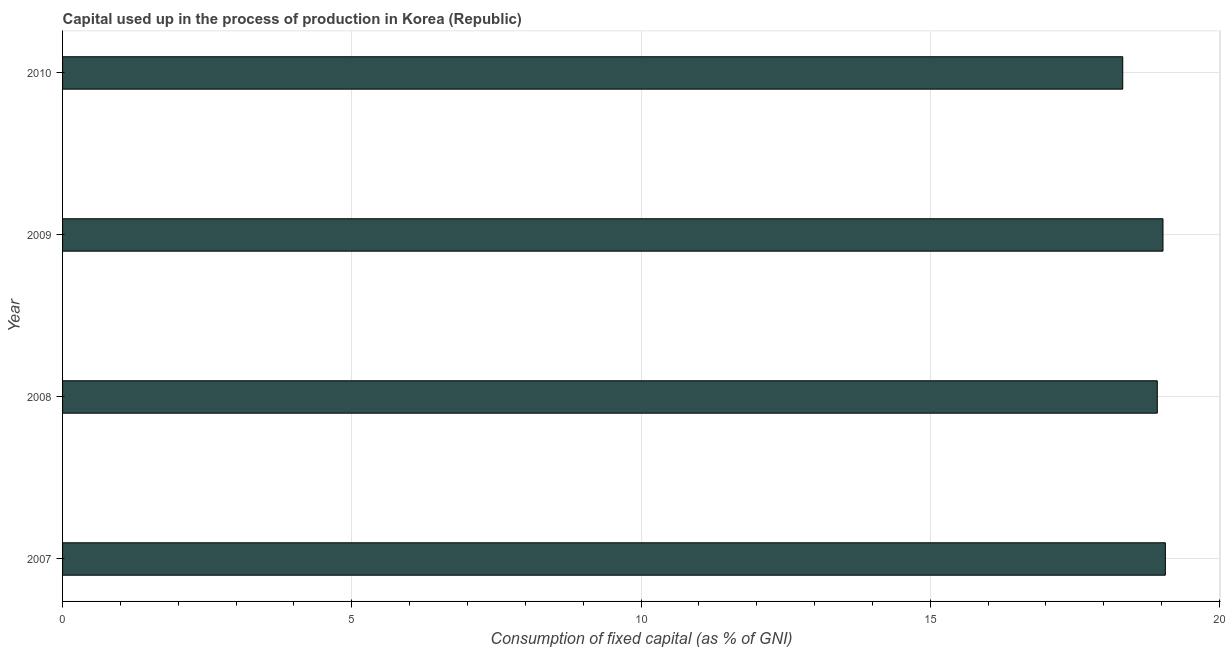Does the graph contain grids?
Offer a very short reply. Yes. What is the title of the graph?
Keep it short and to the point. Capital used up in the process of production in Korea (Republic). What is the label or title of the X-axis?
Provide a succinct answer. Consumption of fixed capital (as % of GNI). What is the consumption of fixed capital in 2009?
Your response must be concise. 19.02. Across all years, what is the maximum consumption of fixed capital?
Your answer should be very brief. 19.06. Across all years, what is the minimum consumption of fixed capital?
Offer a terse response. 18.33. In which year was the consumption of fixed capital maximum?
Offer a terse response. 2007. What is the sum of the consumption of fixed capital?
Ensure brevity in your answer.  75.34. What is the difference between the consumption of fixed capital in 2008 and 2009?
Offer a terse response. -0.1. What is the average consumption of fixed capital per year?
Your response must be concise. 18.84. What is the median consumption of fixed capital?
Your answer should be compact. 18.97. In how many years, is the consumption of fixed capital greater than 15 %?
Provide a short and direct response. 4. Do a majority of the years between 2008 and 2009 (inclusive) have consumption of fixed capital greater than 3 %?
Ensure brevity in your answer.  Yes. What is the ratio of the consumption of fixed capital in 2007 to that in 2008?
Offer a terse response. 1.01. Is the difference between the consumption of fixed capital in 2008 and 2010 greater than the difference between any two years?
Offer a terse response. No. What is the difference between the highest and the second highest consumption of fixed capital?
Offer a terse response. 0.04. Is the sum of the consumption of fixed capital in 2007 and 2010 greater than the maximum consumption of fixed capital across all years?
Your answer should be very brief. Yes. What is the difference between the highest and the lowest consumption of fixed capital?
Your answer should be compact. 0.74. In how many years, is the consumption of fixed capital greater than the average consumption of fixed capital taken over all years?
Offer a very short reply. 3. Are all the bars in the graph horizontal?
Your answer should be very brief. Yes. Are the values on the major ticks of X-axis written in scientific E-notation?
Your answer should be compact. No. What is the Consumption of fixed capital (as % of GNI) in 2007?
Offer a very short reply. 19.06. What is the Consumption of fixed capital (as % of GNI) in 2008?
Offer a very short reply. 18.92. What is the Consumption of fixed capital (as % of GNI) of 2009?
Your answer should be very brief. 19.02. What is the Consumption of fixed capital (as % of GNI) in 2010?
Provide a succinct answer. 18.33. What is the difference between the Consumption of fixed capital (as % of GNI) in 2007 and 2008?
Make the answer very short. 0.14. What is the difference between the Consumption of fixed capital (as % of GNI) in 2007 and 2009?
Ensure brevity in your answer.  0.04. What is the difference between the Consumption of fixed capital (as % of GNI) in 2007 and 2010?
Your answer should be very brief. 0.74. What is the difference between the Consumption of fixed capital (as % of GNI) in 2008 and 2009?
Provide a short and direct response. -0.1. What is the difference between the Consumption of fixed capital (as % of GNI) in 2008 and 2010?
Your response must be concise. 0.6. What is the difference between the Consumption of fixed capital (as % of GNI) in 2009 and 2010?
Your answer should be very brief. 0.7. What is the ratio of the Consumption of fixed capital (as % of GNI) in 2007 to that in 2008?
Ensure brevity in your answer.  1.01. What is the ratio of the Consumption of fixed capital (as % of GNI) in 2007 to that in 2009?
Your answer should be compact. 1. What is the ratio of the Consumption of fixed capital (as % of GNI) in 2007 to that in 2010?
Give a very brief answer. 1.04. What is the ratio of the Consumption of fixed capital (as % of GNI) in 2008 to that in 2009?
Your response must be concise. 0.99. What is the ratio of the Consumption of fixed capital (as % of GNI) in 2008 to that in 2010?
Offer a terse response. 1.03. What is the ratio of the Consumption of fixed capital (as % of GNI) in 2009 to that in 2010?
Provide a short and direct response. 1.04. 